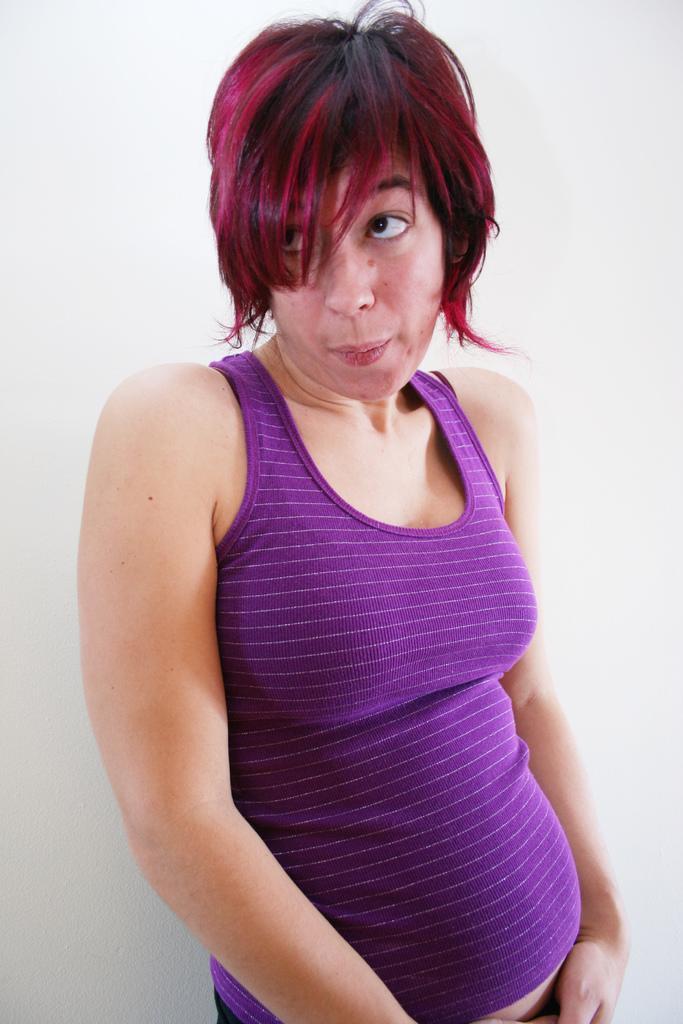Describe this image in one or two sentences. In this image we can see a woman is standing at the wall. 